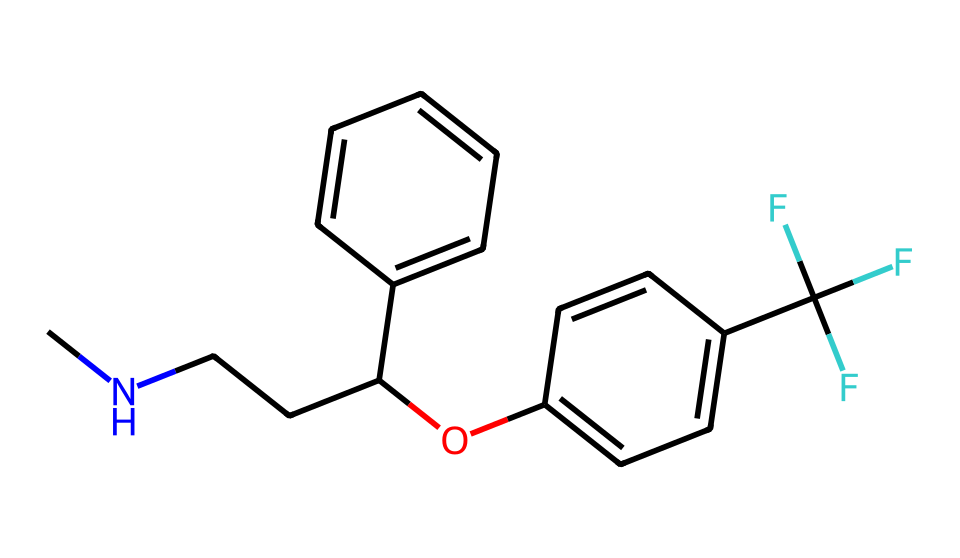What is the molecular formula of fluoxetine? The SMILES representation can be analyzed to count the number of each type of atom present. The structure contains carbon (C), hydrogen (H), nitrogen (N), and oxygen (O) atoms. Specifically, there are 17 carbon atoms, 18 hydrogen atoms, 1 nitrogen atom, and 1 oxygen atom, leading to the formula C17H18F3N.O.
Answer: C17H18F3N.O How many rings are present in fluoxetine? By examining the chemical structure represented by the SMILES, we can identify the existence of cyclic components. In this case, there are two aromatic rings noted, specifically denoted by the 'c' in the SMILES. Hence, we conclude there are two rings.
Answer: 2 What functional groups does fluoxetine contain? The chemical structure features several functional groups identifiable from the SMILES. The presence of an alcohol (–OH) and a trifluoromethyl (–CF3) group can be observed. Both contribute to the medicinal properties of fluoxetine.
Answer: alcohol, trifluoromethyl What is the role of the trifluoromethyl group in fluoxetine? The trifluoromethyl group (–CF3) is known to enhance the lipophilicity of many medicinal compounds, including fluoxetine, which helps in crossing the blood-brain barrier and improving bioavailability. This is crucial for its effectiveness as an antidepressant.
Answer: increase lipophilicity How does the hydroxyl group affect fluoxetine's properties? The hydroxyl group (–OH) adds polarity to the fluoxetine molecule, which influences its solubility and interaction with biological targets. This enhances fluoxetine's ability to bind with receptors in the brain, contributing to its therapeutic effects.
Answer: enhances solubility Is fluoxetine a chiral compound? The molecular structure shows that there is a carbon atom bonded to four different substituents, indicating chirality. This is significant since different enantiomers can exhibit different pharmacological properties.
Answer: yes 